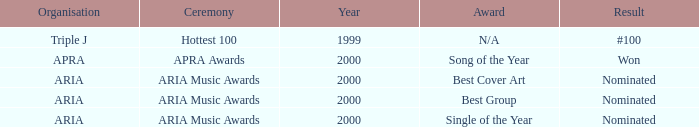What's the award for #100? N/A. 